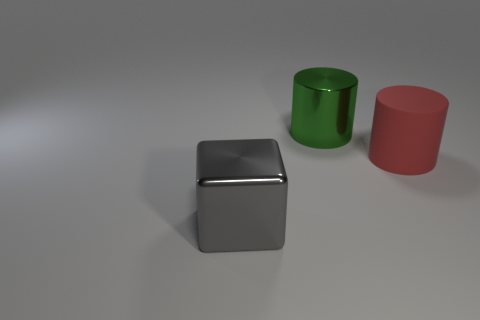There is a cube; how many gray objects are on the right side of it?
Keep it short and to the point. 0. Are there an equal number of shiny objects in front of the green cylinder and large green cylinders that are behind the big block?
Your answer should be very brief. Yes. What is the shape of the big metal thing that is in front of the large matte cylinder?
Keep it short and to the point. Cube. Are the object to the right of the green cylinder and the large object to the left of the green cylinder made of the same material?
Provide a succinct answer. No. There is a big red thing; what shape is it?
Ensure brevity in your answer.  Cylinder. Are there an equal number of red cylinders that are to the left of the metallic cylinder and rubber things?
Ensure brevity in your answer.  No. Are there any tiny cubes made of the same material as the green cylinder?
Your response must be concise. No. There is a big metallic thing behind the gray metallic block; does it have the same shape as the large object that is in front of the red rubber object?
Give a very brief answer. No. Are there any green cylinders?
Offer a terse response. Yes. What is the color of the other cylinder that is the same size as the red cylinder?
Your response must be concise. Green. 